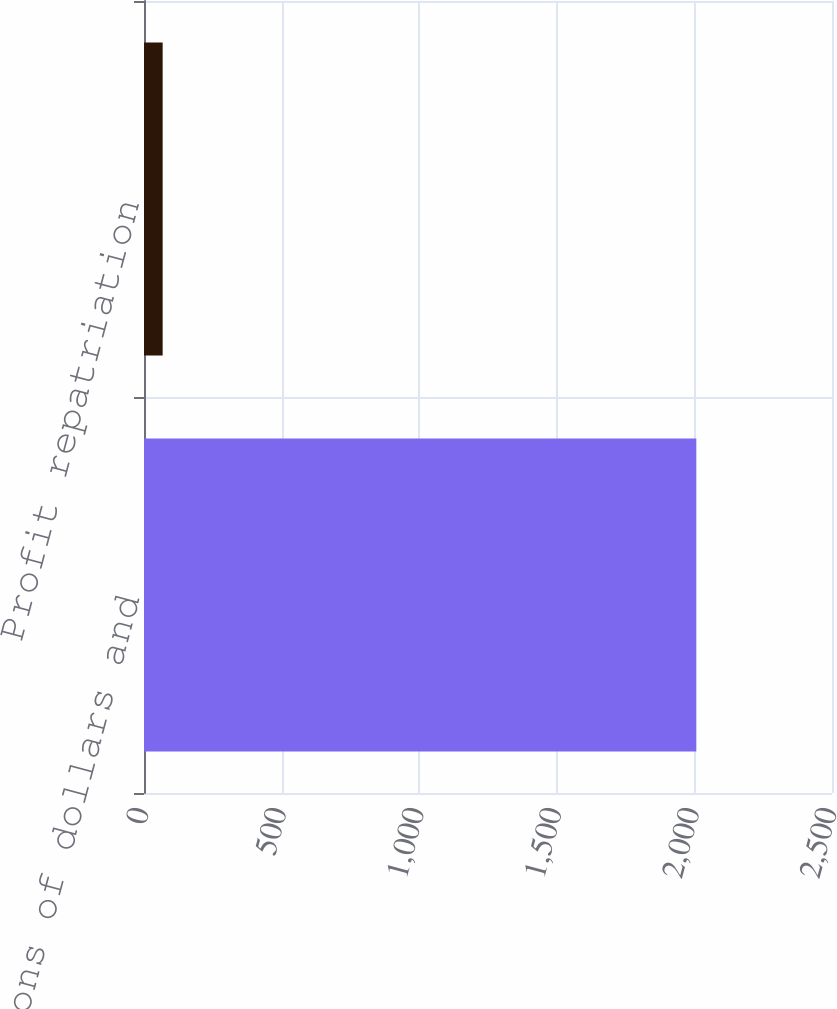Convert chart. <chart><loc_0><loc_0><loc_500><loc_500><bar_chart><fcel>(In millions of dollars and<fcel>Profit repatriation<nl><fcel>2007<fcel>67.8<nl></chart> 